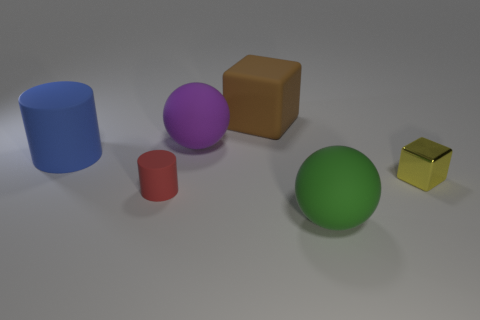Is the number of large things that are behind the shiny thing the same as the number of tiny red rubber spheres? Upon inspecting the image, there are two large objects behind the shiny yellow cube: a blue cylinder and a purple sphere. There is only one tiny red rubber sphere visible in the image; therefore, the number of large things behind the shiny object is not the same as the number of tiny red rubber spheres. 